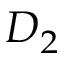Convert formula to latex. <formula><loc_0><loc_0><loc_500><loc_500>D _ { 2 }</formula> 